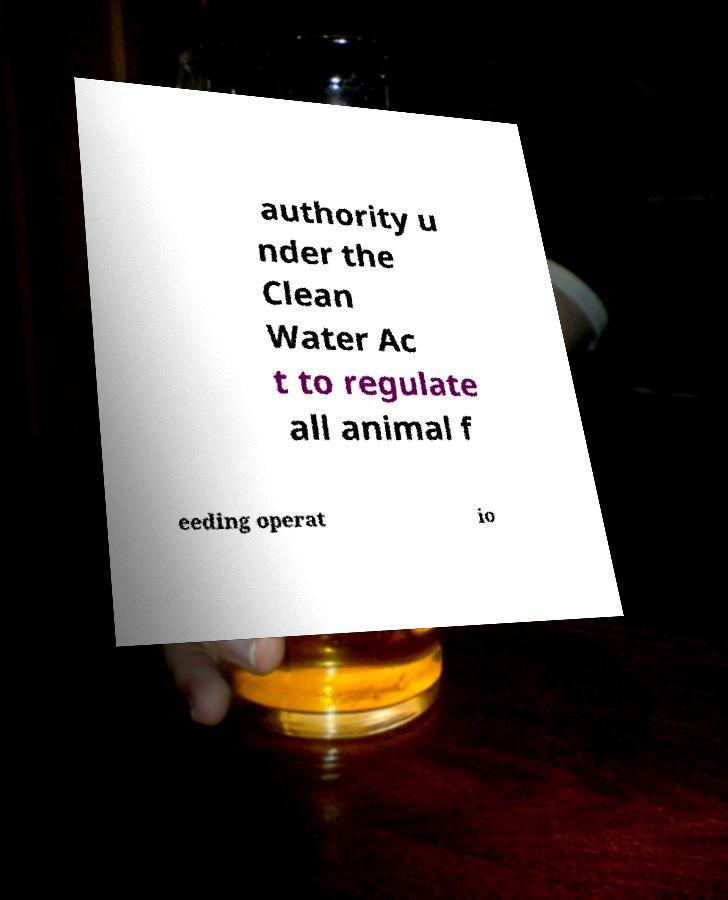For documentation purposes, I need the text within this image transcribed. Could you provide that? authority u nder the Clean Water Ac t to regulate all animal f eeding operat io 